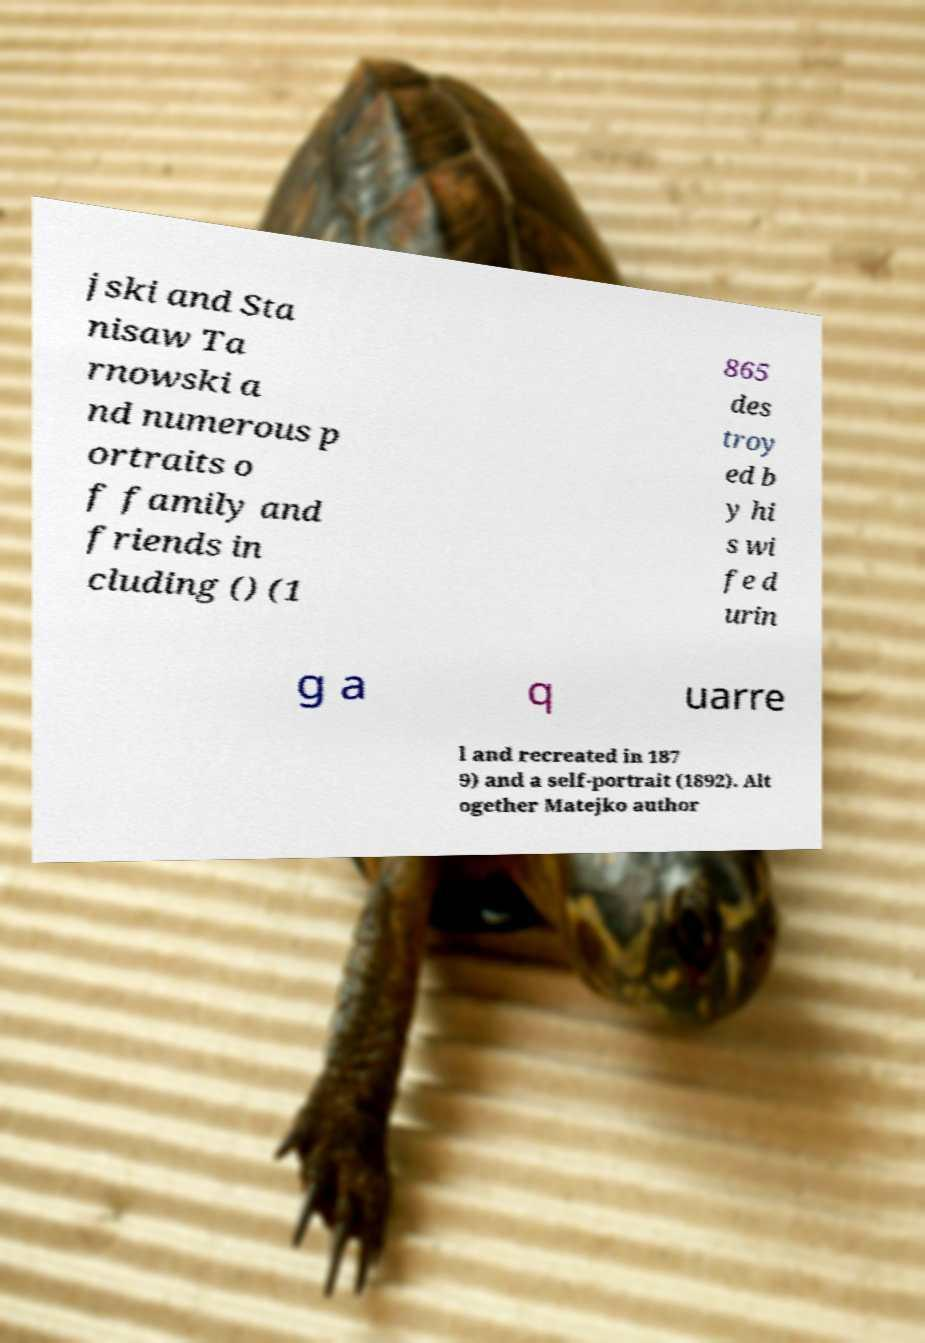Please identify and transcribe the text found in this image. jski and Sta nisaw Ta rnowski a nd numerous p ortraits o f family and friends in cluding () (1 865 des troy ed b y hi s wi fe d urin g a q uarre l and recreated in 187 9) and a self-portrait (1892). Alt ogether Matejko author 